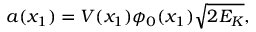<formula> <loc_0><loc_0><loc_500><loc_500>a ( x _ { 1 } ) = V ( x _ { 1 } ) \phi _ { 0 } ( x _ { 1 } ) \sqrt { 2 E _ { K } } ,</formula> 